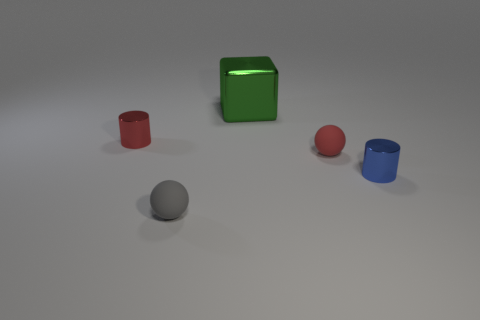Add 3 blue metallic cylinders. How many objects exist? 8 Subtract all cylinders. How many objects are left? 3 Subtract all large green shiny things. Subtract all blue metallic cylinders. How many objects are left? 3 Add 4 blue objects. How many blue objects are left? 5 Add 1 small objects. How many small objects exist? 5 Subtract 1 gray spheres. How many objects are left? 4 